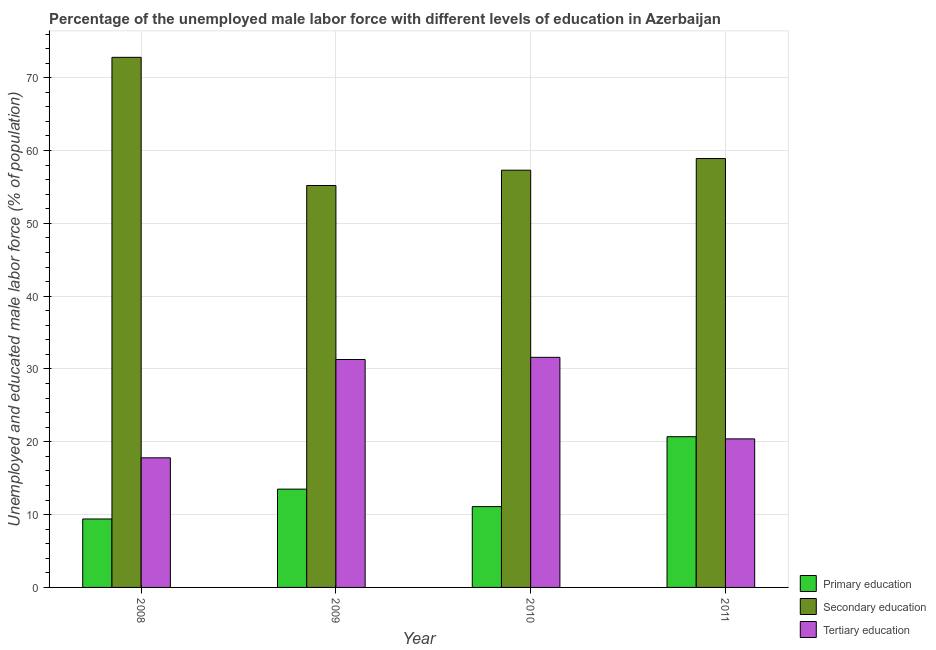How many different coloured bars are there?
Give a very brief answer. 3. Are the number of bars on each tick of the X-axis equal?
Make the answer very short. Yes. How many bars are there on the 4th tick from the left?
Your response must be concise. 3. What is the label of the 4th group of bars from the left?
Your answer should be very brief. 2011. What is the percentage of male labor force who received secondary education in 2010?
Provide a succinct answer. 57.3. Across all years, what is the maximum percentage of male labor force who received secondary education?
Offer a very short reply. 72.8. Across all years, what is the minimum percentage of male labor force who received primary education?
Provide a short and direct response. 9.4. In which year was the percentage of male labor force who received tertiary education maximum?
Keep it short and to the point. 2010. What is the total percentage of male labor force who received tertiary education in the graph?
Keep it short and to the point. 101.1. What is the difference between the percentage of male labor force who received primary education in 2009 and that in 2010?
Make the answer very short. 2.4. What is the difference between the percentage of male labor force who received tertiary education in 2008 and the percentage of male labor force who received secondary education in 2009?
Your answer should be compact. -13.5. What is the average percentage of male labor force who received secondary education per year?
Give a very brief answer. 61.05. In the year 2009, what is the difference between the percentage of male labor force who received secondary education and percentage of male labor force who received tertiary education?
Offer a terse response. 0. In how many years, is the percentage of male labor force who received secondary education greater than 40 %?
Your answer should be compact. 4. What is the ratio of the percentage of male labor force who received tertiary education in 2008 to that in 2010?
Keep it short and to the point. 0.56. Is the difference between the percentage of male labor force who received tertiary education in 2009 and 2011 greater than the difference between the percentage of male labor force who received primary education in 2009 and 2011?
Provide a succinct answer. No. What is the difference between the highest and the second highest percentage of male labor force who received tertiary education?
Ensure brevity in your answer.  0.3. What is the difference between the highest and the lowest percentage of male labor force who received tertiary education?
Ensure brevity in your answer.  13.8. In how many years, is the percentage of male labor force who received secondary education greater than the average percentage of male labor force who received secondary education taken over all years?
Provide a short and direct response. 1. What does the 2nd bar from the left in 2008 represents?
Make the answer very short. Secondary education. What does the 1st bar from the right in 2008 represents?
Your answer should be very brief. Tertiary education. Is it the case that in every year, the sum of the percentage of male labor force who received primary education and percentage of male labor force who received secondary education is greater than the percentage of male labor force who received tertiary education?
Your answer should be compact. Yes. What is the difference between two consecutive major ticks on the Y-axis?
Provide a succinct answer. 10. How are the legend labels stacked?
Ensure brevity in your answer.  Vertical. What is the title of the graph?
Your response must be concise. Percentage of the unemployed male labor force with different levels of education in Azerbaijan. What is the label or title of the X-axis?
Ensure brevity in your answer.  Year. What is the label or title of the Y-axis?
Ensure brevity in your answer.  Unemployed and educated male labor force (% of population). What is the Unemployed and educated male labor force (% of population) in Primary education in 2008?
Keep it short and to the point. 9.4. What is the Unemployed and educated male labor force (% of population) in Secondary education in 2008?
Ensure brevity in your answer.  72.8. What is the Unemployed and educated male labor force (% of population) in Tertiary education in 2008?
Keep it short and to the point. 17.8. What is the Unemployed and educated male labor force (% of population) of Primary education in 2009?
Your response must be concise. 13.5. What is the Unemployed and educated male labor force (% of population) in Secondary education in 2009?
Your answer should be very brief. 55.2. What is the Unemployed and educated male labor force (% of population) of Tertiary education in 2009?
Provide a succinct answer. 31.3. What is the Unemployed and educated male labor force (% of population) of Primary education in 2010?
Your answer should be compact. 11.1. What is the Unemployed and educated male labor force (% of population) in Secondary education in 2010?
Give a very brief answer. 57.3. What is the Unemployed and educated male labor force (% of population) of Tertiary education in 2010?
Your answer should be very brief. 31.6. What is the Unemployed and educated male labor force (% of population) in Primary education in 2011?
Give a very brief answer. 20.7. What is the Unemployed and educated male labor force (% of population) of Secondary education in 2011?
Keep it short and to the point. 58.9. What is the Unemployed and educated male labor force (% of population) in Tertiary education in 2011?
Offer a very short reply. 20.4. Across all years, what is the maximum Unemployed and educated male labor force (% of population) in Primary education?
Give a very brief answer. 20.7. Across all years, what is the maximum Unemployed and educated male labor force (% of population) in Secondary education?
Your answer should be compact. 72.8. Across all years, what is the maximum Unemployed and educated male labor force (% of population) of Tertiary education?
Make the answer very short. 31.6. Across all years, what is the minimum Unemployed and educated male labor force (% of population) of Primary education?
Your response must be concise. 9.4. Across all years, what is the minimum Unemployed and educated male labor force (% of population) in Secondary education?
Provide a succinct answer. 55.2. Across all years, what is the minimum Unemployed and educated male labor force (% of population) of Tertiary education?
Ensure brevity in your answer.  17.8. What is the total Unemployed and educated male labor force (% of population) in Primary education in the graph?
Ensure brevity in your answer.  54.7. What is the total Unemployed and educated male labor force (% of population) of Secondary education in the graph?
Make the answer very short. 244.2. What is the total Unemployed and educated male labor force (% of population) of Tertiary education in the graph?
Ensure brevity in your answer.  101.1. What is the difference between the Unemployed and educated male labor force (% of population) of Tertiary education in 2008 and that in 2009?
Make the answer very short. -13.5. What is the difference between the Unemployed and educated male labor force (% of population) of Primary education in 2008 and that in 2010?
Give a very brief answer. -1.7. What is the difference between the Unemployed and educated male labor force (% of population) of Secondary education in 2008 and that in 2010?
Your response must be concise. 15.5. What is the difference between the Unemployed and educated male labor force (% of population) in Tertiary education in 2008 and that in 2010?
Ensure brevity in your answer.  -13.8. What is the difference between the Unemployed and educated male labor force (% of population) in Secondary education in 2008 and that in 2011?
Your answer should be very brief. 13.9. What is the difference between the Unemployed and educated male labor force (% of population) in Primary education in 2009 and that in 2010?
Offer a very short reply. 2.4. What is the difference between the Unemployed and educated male labor force (% of population) in Secondary education in 2009 and that in 2010?
Provide a succinct answer. -2.1. What is the difference between the Unemployed and educated male labor force (% of population) of Tertiary education in 2009 and that in 2010?
Provide a short and direct response. -0.3. What is the difference between the Unemployed and educated male labor force (% of population) in Primary education in 2009 and that in 2011?
Make the answer very short. -7.2. What is the difference between the Unemployed and educated male labor force (% of population) of Secondary education in 2009 and that in 2011?
Ensure brevity in your answer.  -3.7. What is the difference between the Unemployed and educated male labor force (% of population) in Tertiary education in 2009 and that in 2011?
Provide a short and direct response. 10.9. What is the difference between the Unemployed and educated male labor force (% of population) of Tertiary education in 2010 and that in 2011?
Provide a succinct answer. 11.2. What is the difference between the Unemployed and educated male labor force (% of population) of Primary education in 2008 and the Unemployed and educated male labor force (% of population) of Secondary education in 2009?
Your response must be concise. -45.8. What is the difference between the Unemployed and educated male labor force (% of population) of Primary education in 2008 and the Unemployed and educated male labor force (% of population) of Tertiary education in 2009?
Make the answer very short. -21.9. What is the difference between the Unemployed and educated male labor force (% of population) of Secondary education in 2008 and the Unemployed and educated male labor force (% of population) of Tertiary education in 2009?
Your answer should be very brief. 41.5. What is the difference between the Unemployed and educated male labor force (% of population) of Primary education in 2008 and the Unemployed and educated male labor force (% of population) of Secondary education in 2010?
Provide a short and direct response. -47.9. What is the difference between the Unemployed and educated male labor force (% of population) in Primary education in 2008 and the Unemployed and educated male labor force (% of population) in Tertiary education in 2010?
Provide a succinct answer. -22.2. What is the difference between the Unemployed and educated male labor force (% of population) in Secondary education in 2008 and the Unemployed and educated male labor force (% of population) in Tertiary education in 2010?
Make the answer very short. 41.2. What is the difference between the Unemployed and educated male labor force (% of population) of Primary education in 2008 and the Unemployed and educated male labor force (% of population) of Secondary education in 2011?
Ensure brevity in your answer.  -49.5. What is the difference between the Unemployed and educated male labor force (% of population) of Secondary education in 2008 and the Unemployed and educated male labor force (% of population) of Tertiary education in 2011?
Keep it short and to the point. 52.4. What is the difference between the Unemployed and educated male labor force (% of population) of Primary education in 2009 and the Unemployed and educated male labor force (% of population) of Secondary education in 2010?
Give a very brief answer. -43.8. What is the difference between the Unemployed and educated male labor force (% of population) in Primary education in 2009 and the Unemployed and educated male labor force (% of population) in Tertiary education in 2010?
Your answer should be compact. -18.1. What is the difference between the Unemployed and educated male labor force (% of population) in Secondary education in 2009 and the Unemployed and educated male labor force (% of population) in Tertiary education in 2010?
Keep it short and to the point. 23.6. What is the difference between the Unemployed and educated male labor force (% of population) of Primary education in 2009 and the Unemployed and educated male labor force (% of population) of Secondary education in 2011?
Offer a very short reply. -45.4. What is the difference between the Unemployed and educated male labor force (% of population) in Secondary education in 2009 and the Unemployed and educated male labor force (% of population) in Tertiary education in 2011?
Offer a terse response. 34.8. What is the difference between the Unemployed and educated male labor force (% of population) of Primary education in 2010 and the Unemployed and educated male labor force (% of population) of Secondary education in 2011?
Your answer should be compact. -47.8. What is the difference between the Unemployed and educated male labor force (% of population) in Secondary education in 2010 and the Unemployed and educated male labor force (% of population) in Tertiary education in 2011?
Your answer should be compact. 36.9. What is the average Unemployed and educated male labor force (% of population) of Primary education per year?
Keep it short and to the point. 13.68. What is the average Unemployed and educated male labor force (% of population) in Secondary education per year?
Your response must be concise. 61.05. What is the average Unemployed and educated male labor force (% of population) of Tertiary education per year?
Give a very brief answer. 25.27. In the year 2008, what is the difference between the Unemployed and educated male labor force (% of population) of Primary education and Unemployed and educated male labor force (% of population) of Secondary education?
Your answer should be compact. -63.4. In the year 2008, what is the difference between the Unemployed and educated male labor force (% of population) of Primary education and Unemployed and educated male labor force (% of population) of Tertiary education?
Your response must be concise. -8.4. In the year 2008, what is the difference between the Unemployed and educated male labor force (% of population) of Secondary education and Unemployed and educated male labor force (% of population) of Tertiary education?
Your response must be concise. 55. In the year 2009, what is the difference between the Unemployed and educated male labor force (% of population) in Primary education and Unemployed and educated male labor force (% of population) in Secondary education?
Provide a short and direct response. -41.7. In the year 2009, what is the difference between the Unemployed and educated male labor force (% of population) in Primary education and Unemployed and educated male labor force (% of population) in Tertiary education?
Offer a terse response. -17.8. In the year 2009, what is the difference between the Unemployed and educated male labor force (% of population) of Secondary education and Unemployed and educated male labor force (% of population) of Tertiary education?
Give a very brief answer. 23.9. In the year 2010, what is the difference between the Unemployed and educated male labor force (% of population) of Primary education and Unemployed and educated male labor force (% of population) of Secondary education?
Give a very brief answer. -46.2. In the year 2010, what is the difference between the Unemployed and educated male labor force (% of population) in Primary education and Unemployed and educated male labor force (% of population) in Tertiary education?
Keep it short and to the point. -20.5. In the year 2010, what is the difference between the Unemployed and educated male labor force (% of population) of Secondary education and Unemployed and educated male labor force (% of population) of Tertiary education?
Make the answer very short. 25.7. In the year 2011, what is the difference between the Unemployed and educated male labor force (% of population) of Primary education and Unemployed and educated male labor force (% of population) of Secondary education?
Offer a terse response. -38.2. In the year 2011, what is the difference between the Unemployed and educated male labor force (% of population) in Primary education and Unemployed and educated male labor force (% of population) in Tertiary education?
Give a very brief answer. 0.3. In the year 2011, what is the difference between the Unemployed and educated male labor force (% of population) in Secondary education and Unemployed and educated male labor force (% of population) in Tertiary education?
Make the answer very short. 38.5. What is the ratio of the Unemployed and educated male labor force (% of population) of Primary education in 2008 to that in 2009?
Your answer should be compact. 0.7. What is the ratio of the Unemployed and educated male labor force (% of population) in Secondary education in 2008 to that in 2009?
Your response must be concise. 1.32. What is the ratio of the Unemployed and educated male labor force (% of population) in Tertiary education in 2008 to that in 2009?
Offer a very short reply. 0.57. What is the ratio of the Unemployed and educated male labor force (% of population) of Primary education in 2008 to that in 2010?
Offer a terse response. 0.85. What is the ratio of the Unemployed and educated male labor force (% of population) of Secondary education in 2008 to that in 2010?
Keep it short and to the point. 1.27. What is the ratio of the Unemployed and educated male labor force (% of population) of Tertiary education in 2008 to that in 2010?
Offer a terse response. 0.56. What is the ratio of the Unemployed and educated male labor force (% of population) of Primary education in 2008 to that in 2011?
Provide a short and direct response. 0.45. What is the ratio of the Unemployed and educated male labor force (% of population) of Secondary education in 2008 to that in 2011?
Your answer should be compact. 1.24. What is the ratio of the Unemployed and educated male labor force (% of population) in Tertiary education in 2008 to that in 2011?
Keep it short and to the point. 0.87. What is the ratio of the Unemployed and educated male labor force (% of population) in Primary education in 2009 to that in 2010?
Offer a very short reply. 1.22. What is the ratio of the Unemployed and educated male labor force (% of population) in Secondary education in 2009 to that in 2010?
Keep it short and to the point. 0.96. What is the ratio of the Unemployed and educated male labor force (% of population) of Primary education in 2009 to that in 2011?
Provide a short and direct response. 0.65. What is the ratio of the Unemployed and educated male labor force (% of population) in Secondary education in 2009 to that in 2011?
Your response must be concise. 0.94. What is the ratio of the Unemployed and educated male labor force (% of population) in Tertiary education in 2009 to that in 2011?
Ensure brevity in your answer.  1.53. What is the ratio of the Unemployed and educated male labor force (% of population) in Primary education in 2010 to that in 2011?
Your answer should be very brief. 0.54. What is the ratio of the Unemployed and educated male labor force (% of population) of Secondary education in 2010 to that in 2011?
Your answer should be very brief. 0.97. What is the ratio of the Unemployed and educated male labor force (% of population) in Tertiary education in 2010 to that in 2011?
Your answer should be very brief. 1.55. What is the difference between the highest and the second highest Unemployed and educated male labor force (% of population) of Secondary education?
Provide a short and direct response. 13.9. What is the difference between the highest and the second highest Unemployed and educated male labor force (% of population) in Tertiary education?
Your response must be concise. 0.3. What is the difference between the highest and the lowest Unemployed and educated male labor force (% of population) of Primary education?
Ensure brevity in your answer.  11.3. What is the difference between the highest and the lowest Unemployed and educated male labor force (% of population) of Tertiary education?
Offer a very short reply. 13.8. 